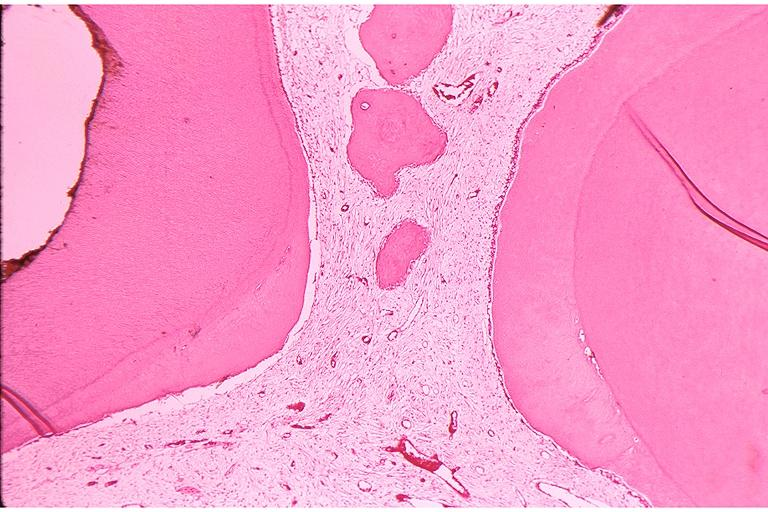what does this image show?
Answer the question using a single word or phrase. Secondary dentin and pulp calcification 